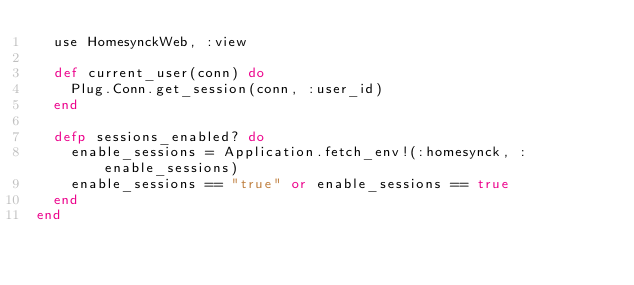<code> <loc_0><loc_0><loc_500><loc_500><_Elixir_>  use HomesynckWeb, :view

  def current_user(conn) do
    Plug.Conn.get_session(conn, :user_id)
  end

  defp sessions_enabled? do
    enable_sessions = Application.fetch_env!(:homesynck, :enable_sessions)
    enable_sessions == "true" or enable_sessions == true
  end
end
</code> 